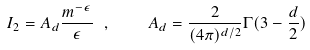<formula> <loc_0><loc_0><loc_500><loc_500>I _ { 2 } = A _ { d } \frac { m ^ { - \epsilon } } { \epsilon } \ , \quad A _ { d } = \frac { 2 } { ( 4 \pi ) ^ { d / 2 } } \Gamma ( 3 - \frac { d } { 2 } )</formula> 